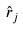Convert formula to latex. <formula><loc_0><loc_0><loc_500><loc_500>\hat { r } _ { j }</formula> 